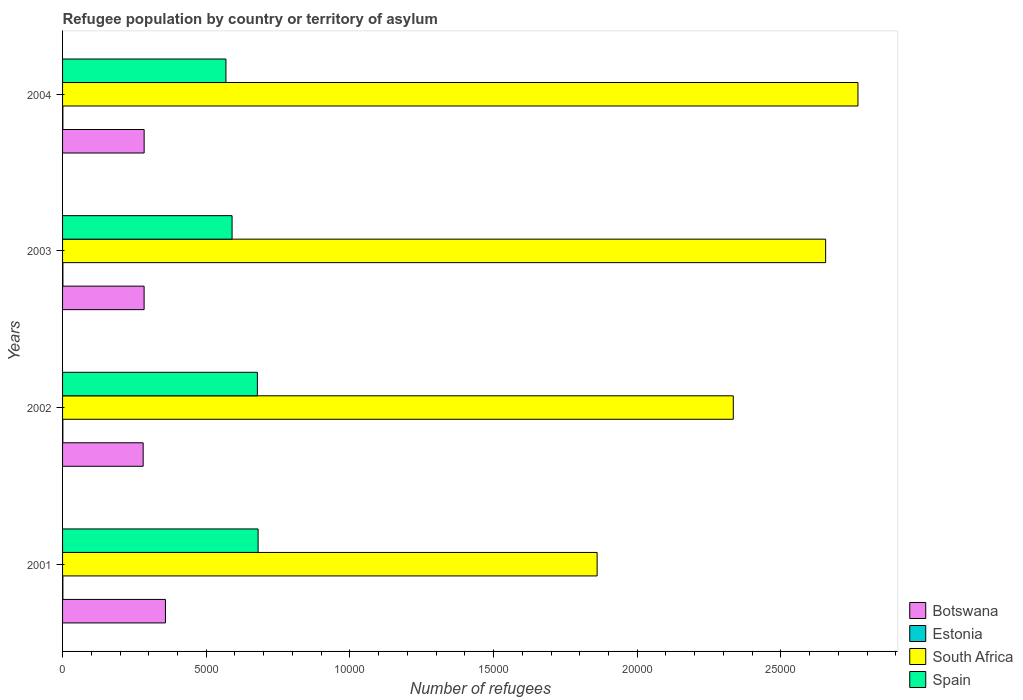How many groups of bars are there?
Offer a very short reply. 4. Are the number of bars on each tick of the Y-axis equal?
Ensure brevity in your answer.  Yes. How many bars are there on the 2nd tick from the bottom?
Give a very brief answer. 4. What is the number of refugees in South Africa in 2004?
Make the answer very short. 2.77e+04. Across all years, what is the minimum number of refugees in Spain?
Give a very brief answer. 5686. In which year was the number of refugees in Estonia maximum?
Your answer should be compact. 2003. In which year was the number of refugees in Estonia minimum?
Your answer should be very brief. 2002. What is the total number of refugees in Spain in the graph?
Your answer should be compact. 2.52e+04. What is the difference between the number of refugees in South Africa in 2001 and that in 2003?
Provide a short and direct response. -7953. What is the difference between the number of refugees in Botswana in 2001 and the number of refugees in Spain in 2003?
Your answer should be compact. -2319. What is the average number of refugees in South Africa per year?
Your response must be concise. 2.40e+04. In the year 2001, what is the difference between the number of refugees in Estonia and number of refugees in Spain?
Provide a short and direct response. -6795. In how many years, is the number of refugees in Estonia greater than 19000 ?
Ensure brevity in your answer.  0. What is the ratio of the number of refugees in Estonia in 2002 to that in 2003?
Your answer should be very brief. 0.83. Is the number of refugees in Spain in 2003 less than that in 2004?
Your answer should be compact. No. What is the difference between the highest and the second highest number of refugees in South Africa?
Make the answer very short. 1125. What does the 4th bar from the top in 2004 represents?
Your answer should be compact. Botswana. What does the 3rd bar from the bottom in 2004 represents?
Give a very brief answer. South Africa. Is it the case that in every year, the sum of the number of refugees in Spain and number of refugees in Botswana is greater than the number of refugees in Estonia?
Make the answer very short. Yes. How many bars are there?
Your response must be concise. 16. Are all the bars in the graph horizontal?
Provide a short and direct response. Yes. Are the values on the major ticks of X-axis written in scientific E-notation?
Give a very brief answer. No. Does the graph contain any zero values?
Offer a very short reply. No. Where does the legend appear in the graph?
Offer a terse response. Bottom right. How are the legend labels stacked?
Ensure brevity in your answer.  Vertical. What is the title of the graph?
Offer a very short reply. Refugee population by country or territory of asylum. Does "American Samoa" appear as one of the legend labels in the graph?
Provide a succinct answer. No. What is the label or title of the X-axis?
Keep it short and to the point. Number of refugees. What is the Number of refugees of Botswana in 2001?
Your response must be concise. 3581. What is the Number of refugees in Estonia in 2001?
Keep it short and to the point. 11. What is the Number of refugees in South Africa in 2001?
Ensure brevity in your answer.  1.86e+04. What is the Number of refugees of Spain in 2001?
Give a very brief answer. 6806. What is the Number of refugees in Botswana in 2002?
Provide a succinct answer. 2805. What is the Number of refugees of Estonia in 2002?
Give a very brief answer. 10. What is the Number of refugees of South Africa in 2002?
Provide a short and direct response. 2.33e+04. What is the Number of refugees in Spain in 2002?
Offer a terse response. 6780. What is the Number of refugees of Botswana in 2003?
Give a very brief answer. 2838. What is the Number of refugees of South Africa in 2003?
Provide a short and direct response. 2.66e+04. What is the Number of refugees of Spain in 2003?
Ensure brevity in your answer.  5900. What is the Number of refugees in Botswana in 2004?
Offer a terse response. 2839. What is the Number of refugees of Estonia in 2004?
Provide a short and direct response. 11. What is the Number of refugees in South Africa in 2004?
Give a very brief answer. 2.77e+04. What is the Number of refugees of Spain in 2004?
Make the answer very short. 5686. Across all years, what is the maximum Number of refugees in Botswana?
Your answer should be very brief. 3581. Across all years, what is the maximum Number of refugees in Estonia?
Ensure brevity in your answer.  12. Across all years, what is the maximum Number of refugees of South Africa?
Offer a terse response. 2.77e+04. Across all years, what is the maximum Number of refugees in Spain?
Give a very brief answer. 6806. Across all years, what is the minimum Number of refugees of Botswana?
Offer a terse response. 2805. Across all years, what is the minimum Number of refugees of Estonia?
Your answer should be very brief. 10. Across all years, what is the minimum Number of refugees in South Africa?
Give a very brief answer. 1.86e+04. Across all years, what is the minimum Number of refugees of Spain?
Provide a short and direct response. 5686. What is the total Number of refugees in Botswana in the graph?
Provide a short and direct response. 1.21e+04. What is the total Number of refugees of Estonia in the graph?
Give a very brief answer. 44. What is the total Number of refugees of South Africa in the graph?
Give a very brief answer. 9.62e+04. What is the total Number of refugees of Spain in the graph?
Provide a succinct answer. 2.52e+04. What is the difference between the Number of refugees of Botswana in 2001 and that in 2002?
Your answer should be compact. 776. What is the difference between the Number of refugees of Estonia in 2001 and that in 2002?
Give a very brief answer. 1. What is the difference between the Number of refugees in South Africa in 2001 and that in 2002?
Provide a short and direct response. -4739. What is the difference between the Number of refugees in Spain in 2001 and that in 2002?
Give a very brief answer. 26. What is the difference between the Number of refugees in Botswana in 2001 and that in 2003?
Your response must be concise. 743. What is the difference between the Number of refugees in South Africa in 2001 and that in 2003?
Provide a succinct answer. -7953. What is the difference between the Number of refugees in Spain in 2001 and that in 2003?
Offer a terse response. 906. What is the difference between the Number of refugees of Botswana in 2001 and that in 2004?
Your answer should be very brief. 742. What is the difference between the Number of refugees in Estonia in 2001 and that in 2004?
Give a very brief answer. 0. What is the difference between the Number of refugees of South Africa in 2001 and that in 2004?
Offer a very short reply. -9078. What is the difference between the Number of refugees in Spain in 2001 and that in 2004?
Ensure brevity in your answer.  1120. What is the difference between the Number of refugees in Botswana in 2002 and that in 2003?
Your answer should be compact. -33. What is the difference between the Number of refugees in South Africa in 2002 and that in 2003?
Your answer should be very brief. -3214. What is the difference between the Number of refugees of Spain in 2002 and that in 2003?
Offer a very short reply. 880. What is the difference between the Number of refugees in Botswana in 2002 and that in 2004?
Offer a very short reply. -34. What is the difference between the Number of refugees in Estonia in 2002 and that in 2004?
Make the answer very short. -1. What is the difference between the Number of refugees in South Africa in 2002 and that in 2004?
Your answer should be very brief. -4339. What is the difference between the Number of refugees in Spain in 2002 and that in 2004?
Ensure brevity in your answer.  1094. What is the difference between the Number of refugees of Botswana in 2003 and that in 2004?
Make the answer very short. -1. What is the difference between the Number of refugees in South Africa in 2003 and that in 2004?
Provide a short and direct response. -1125. What is the difference between the Number of refugees in Spain in 2003 and that in 2004?
Your answer should be very brief. 214. What is the difference between the Number of refugees of Botswana in 2001 and the Number of refugees of Estonia in 2002?
Make the answer very short. 3571. What is the difference between the Number of refugees of Botswana in 2001 and the Number of refugees of South Africa in 2002?
Make the answer very short. -1.98e+04. What is the difference between the Number of refugees in Botswana in 2001 and the Number of refugees in Spain in 2002?
Provide a short and direct response. -3199. What is the difference between the Number of refugees of Estonia in 2001 and the Number of refugees of South Africa in 2002?
Keep it short and to the point. -2.33e+04. What is the difference between the Number of refugees in Estonia in 2001 and the Number of refugees in Spain in 2002?
Your answer should be compact. -6769. What is the difference between the Number of refugees in South Africa in 2001 and the Number of refugees in Spain in 2002?
Offer a very short reply. 1.18e+04. What is the difference between the Number of refugees in Botswana in 2001 and the Number of refugees in Estonia in 2003?
Give a very brief answer. 3569. What is the difference between the Number of refugees in Botswana in 2001 and the Number of refugees in South Africa in 2003?
Make the answer very short. -2.30e+04. What is the difference between the Number of refugees in Botswana in 2001 and the Number of refugees in Spain in 2003?
Ensure brevity in your answer.  -2319. What is the difference between the Number of refugees of Estonia in 2001 and the Number of refugees of South Africa in 2003?
Give a very brief answer. -2.65e+04. What is the difference between the Number of refugees in Estonia in 2001 and the Number of refugees in Spain in 2003?
Your answer should be compact. -5889. What is the difference between the Number of refugees in South Africa in 2001 and the Number of refugees in Spain in 2003?
Keep it short and to the point. 1.27e+04. What is the difference between the Number of refugees in Botswana in 2001 and the Number of refugees in Estonia in 2004?
Provide a short and direct response. 3570. What is the difference between the Number of refugees of Botswana in 2001 and the Number of refugees of South Africa in 2004?
Ensure brevity in your answer.  -2.41e+04. What is the difference between the Number of refugees of Botswana in 2001 and the Number of refugees of Spain in 2004?
Your response must be concise. -2105. What is the difference between the Number of refugees in Estonia in 2001 and the Number of refugees in South Africa in 2004?
Ensure brevity in your answer.  -2.77e+04. What is the difference between the Number of refugees of Estonia in 2001 and the Number of refugees of Spain in 2004?
Make the answer very short. -5675. What is the difference between the Number of refugees of South Africa in 2001 and the Number of refugees of Spain in 2004?
Your answer should be compact. 1.29e+04. What is the difference between the Number of refugees in Botswana in 2002 and the Number of refugees in Estonia in 2003?
Provide a short and direct response. 2793. What is the difference between the Number of refugees in Botswana in 2002 and the Number of refugees in South Africa in 2003?
Give a very brief answer. -2.38e+04. What is the difference between the Number of refugees of Botswana in 2002 and the Number of refugees of Spain in 2003?
Offer a terse response. -3095. What is the difference between the Number of refugees of Estonia in 2002 and the Number of refugees of South Africa in 2003?
Your answer should be very brief. -2.65e+04. What is the difference between the Number of refugees in Estonia in 2002 and the Number of refugees in Spain in 2003?
Give a very brief answer. -5890. What is the difference between the Number of refugees in South Africa in 2002 and the Number of refugees in Spain in 2003?
Offer a very short reply. 1.74e+04. What is the difference between the Number of refugees in Botswana in 2002 and the Number of refugees in Estonia in 2004?
Your answer should be very brief. 2794. What is the difference between the Number of refugees in Botswana in 2002 and the Number of refugees in South Africa in 2004?
Offer a very short reply. -2.49e+04. What is the difference between the Number of refugees in Botswana in 2002 and the Number of refugees in Spain in 2004?
Offer a very short reply. -2881. What is the difference between the Number of refugees of Estonia in 2002 and the Number of refugees of South Africa in 2004?
Make the answer very short. -2.77e+04. What is the difference between the Number of refugees of Estonia in 2002 and the Number of refugees of Spain in 2004?
Your answer should be very brief. -5676. What is the difference between the Number of refugees of South Africa in 2002 and the Number of refugees of Spain in 2004?
Provide a short and direct response. 1.77e+04. What is the difference between the Number of refugees in Botswana in 2003 and the Number of refugees in Estonia in 2004?
Your response must be concise. 2827. What is the difference between the Number of refugees in Botswana in 2003 and the Number of refugees in South Africa in 2004?
Offer a terse response. -2.48e+04. What is the difference between the Number of refugees of Botswana in 2003 and the Number of refugees of Spain in 2004?
Provide a short and direct response. -2848. What is the difference between the Number of refugees in Estonia in 2003 and the Number of refugees in South Africa in 2004?
Give a very brief answer. -2.77e+04. What is the difference between the Number of refugees of Estonia in 2003 and the Number of refugees of Spain in 2004?
Offer a very short reply. -5674. What is the difference between the Number of refugees of South Africa in 2003 and the Number of refugees of Spain in 2004?
Your answer should be compact. 2.09e+04. What is the average Number of refugees in Botswana per year?
Your response must be concise. 3015.75. What is the average Number of refugees in Estonia per year?
Offer a very short reply. 11. What is the average Number of refugees in South Africa per year?
Make the answer very short. 2.40e+04. What is the average Number of refugees in Spain per year?
Your response must be concise. 6293. In the year 2001, what is the difference between the Number of refugees in Botswana and Number of refugees in Estonia?
Offer a terse response. 3570. In the year 2001, what is the difference between the Number of refugees of Botswana and Number of refugees of South Africa?
Ensure brevity in your answer.  -1.50e+04. In the year 2001, what is the difference between the Number of refugees of Botswana and Number of refugees of Spain?
Ensure brevity in your answer.  -3225. In the year 2001, what is the difference between the Number of refugees of Estonia and Number of refugees of South Africa?
Provide a succinct answer. -1.86e+04. In the year 2001, what is the difference between the Number of refugees in Estonia and Number of refugees in Spain?
Provide a short and direct response. -6795. In the year 2001, what is the difference between the Number of refugees of South Africa and Number of refugees of Spain?
Your answer should be very brief. 1.18e+04. In the year 2002, what is the difference between the Number of refugees of Botswana and Number of refugees of Estonia?
Ensure brevity in your answer.  2795. In the year 2002, what is the difference between the Number of refugees in Botswana and Number of refugees in South Africa?
Your answer should be compact. -2.05e+04. In the year 2002, what is the difference between the Number of refugees of Botswana and Number of refugees of Spain?
Your answer should be very brief. -3975. In the year 2002, what is the difference between the Number of refugees in Estonia and Number of refugees in South Africa?
Offer a terse response. -2.33e+04. In the year 2002, what is the difference between the Number of refugees in Estonia and Number of refugees in Spain?
Your response must be concise. -6770. In the year 2002, what is the difference between the Number of refugees in South Africa and Number of refugees in Spain?
Your answer should be compact. 1.66e+04. In the year 2003, what is the difference between the Number of refugees of Botswana and Number of refugees of Estonia?
Give a very brief answer. 2826. In the year 2003, what is the difference between the Number of refugees of Botswana and Number of refugees of South Africa?
Provide a short and direct response. -2.37e+04. In the year 2003, what is the difference between the Number of refugees in Botswana and Number of refugees in Spain?
Your answer should be very brief. -3062. In the year 2003, what is the difference between the Number of refugees in Estonia and Number of refugees in South Africa?
Offer a very short reply. -2.65e+04. In the year 2003, what is the difference between the Number of refugees of Estonia and Number of refugees of Spain?
Make the answer very short. -5888. In the year 2003, what is the difference between the Number of refugees of South Africa and Number of refugees of Spain?
Provide a short and direct response. 2.07e+04. In the year 2004, what is the difference between the Number of refugees of Botswana and Number of refugees of Estonia?
Provide a succinct answer. 2828. In the year 2004, what is the difference between the Number of refugees in Botswana and Number of refugees in South Africa?
Provide a short and direct response. -2.48e+04. In the year 2004, what is the difference between the Number of refugees of Botswana and Number of refugees of Spain?
Offer a very short reply. -2847. In the year 2004, what is the difference between the Number of refugees of Estonia and Number of refugees of South Africa?
Keep it short and to the point. -2.77e+04. In the year 2004, what is the difference between the Number of refugees of Estonia and Number of refugees of Spain?
Keep it short and to the point. -5675. In the year 2004, what is the difference between the Number of refugees of South Africa and Number of refugees of Spain?
Your answer should be compact. 2.20e+04. What is the ratio of the Number of refugees of Botswana in 2001 to that in 2002?
Make the answer very short. 1.28. What is the ratio of the Number of refugees of South Africa in 2001 to that in 2002?
Keep it short and to the point. 0.8. What is the ratio of the Number of refugees of Spain in 2001 to that in 2002?
Provide a short and direct response. 1. What is the ratio of the Number of refugees of Botswana in 2001 to that in 2003?
Your answer should be compact. 1.26. What is the ratio of the Number of refugees in Estonia in 2001 to that in 2003?
Offer a terse response. 0.92. What is the ratio of the Number of refugees of South Africa in 2001 to that in 2003?
Provide a short and direct response. 0.7. What is the ratio of the Number of refugees of Spain in 2001 to that in 2003?
Ensure brevity in your answer.  1.15. What is the ratio of the Number of refugees in Botswana in 2001 to that in 2004?
Your answer should be compact. 1.26. What is the ratio of the Number of refugees in Estonia in 2001 to that in 2004?
Give a very brief answer. 1. What is the ratio of the Number of refugees of South Africa in 2001 to that in 2004?
Your response must be concise. 0.67. What is the ratio of the Number of refugees of Spain in 2001 to that in 2004?
Give a very brief answer. 1.2. What is the ratio of the Number of refugees of Botswana in 2002 to that in 2003?
Your answer should be very brief. 0.99. What is the ratio of the Number of refugees of South Africa in 2002 to that in 2003?
Your response must be concise. 0.88. What is the ratio of the Number of refugees in Spain in 2002 to that in 2003?
Ensure brevity in your answer.  1.15. What is the ratio of the Number of refugees of Botswana in 2002 to that in 2004?
Provide a short and direct response. 0.99. What is the ratio of the Number of refugees of Estonia in 2002 to that in 2004?
Provide a succinct answer. 0.91. What is the ratio of the Number of refugees in South Africa in 2002 to that in 2004?
Make the answer very short. 0.84. What is the ratio of the Number of refugees of Spain in 2002 to that in 2004?
Your answer should be very brief. 1.19. What is the ratio of the Number of refugees of Botswana in 2003 to that in 2004?
Your answer should be very brief. 1. What is the ratio of the Number of refugees of South Africa in 2003 to that in 2004?
Keep it short and to the point. 0.96. What is the ratio of the Number of refugees in Spain in 2003 to that in 2004?
Provide a short and direct response. 1.04. What is the difference between the highest and the second highest Number of refugees of Botswana?
Offer a very short reply. 742. What is the difference between the highest and the second highest Number of refugees in South Africa?
Provide a short and direct response. 1125. What is the difference between the highest and the second highest Number of refugees in Spain?
Make the answer very short. 26. What is the difference between the highest and the lowest Number of refugees in Botswana?
Offer a terse response. 776. What is the difference between the highest and the lowest Number of refugees in Estonia?
Make the answer very short. 2. What is the difference between the highest and the lowest Number of refugees in South Africa?
Your response must be concise. 9078. What is the difference between the highest and the lowest Number of refugees in Spain?
Offer a terse response. 1120. 